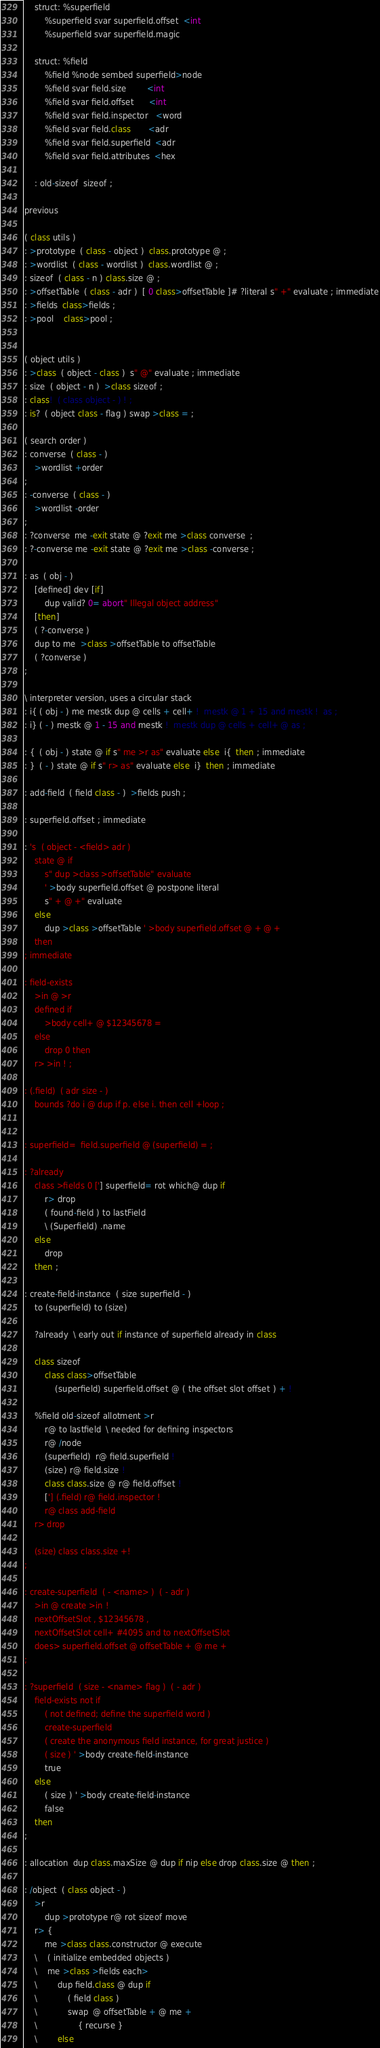<code> <loc_0><loc_0><loc_500><loc_500><_FORTRAN_>    struct: %superfield
        %superfield svar superfield.offset  <int
        %superfield svar superfield.magic
    
    struct: %field 
        %field %node sembed superfield>node 
        %field svar field.size        <int   
        %field svar field.offset      <int      
        %field svar field.inspector   <word    
        %field svar field.class       <adr
        %field svar field.superfield  <adr
        %field svar field.attributes  <hex

    : old-sizeof  sizeof ;    

previous

( class utils )
: >prototype  ( class - object )  class.prototype @ ;
: >wordlist  ( class - wordlist )  class.wordlist @ ;
: sizeof  ( class - n ) class.size @ ;
: >offsetTable  ( class - adr )  [ 0 class>offsetTable ]# ?literal s" +" evaluate ; immediate
: >fields  class>fields ; 
: >pool    class>pool ;


( object utils )
: >class  ( object - class )  s" @" evaluate ; immediate
: size  ( object - n )  >class sizeof ;
: class!  ( class object - ) ! ;
: is?  ( object class - flag ) swap >class = ;

( search order )
: converse  ( class - )
    >wordlist +order
;
: -converse  ( class - )
    >wordlist -order
;
: ?converse  me -exit state @ ?exit me >class converse  ;
: ?-converse me -exit state @ ?exit me >class -converse ;

: as  ( obj - )
    [defined] dev [if]
        dup valid? 0= abort" Illegal object address"
    [then]
    ( ?-converse )
    dup to me  >class >offsetTable to offsetTable
    ( ?converse )
;

\ interpreter version, uses a circular stack
: i{ ( obj - ) me mestk dup @ cells + cell+ !  mestk @ 1 + 15 and mestk !  as ;
: i} ( - ) mestk @ 1 - 15 and mestk !  mestk dup @ cells + cell+ @ as ; 

: {  ( obj - ) state @ if s" me >r as" evaluate else  i{  then ; immediate
: }  ( - ) state @ if s" r> as" evaluate else  i}  then ; immediate

: add-field  ( field class - )  >fields push ;

: superfield.offset ; immediate

: 's  ( object - <field> adr )
    state @ if
        s" dup >class >offsetTable" evaluate
        ' >body superfield.offset @ postpone literal
        s" + @ +" evaluate
    else
        dup >class >offsetTable ' >body superfield.offset @ + @ +
    then
; immediate

: field-exists
    >in @ >r
    defined if
        >body cell+ @ $12345678 =
    else
        drop 0 then
    r> >in ! ;

: (.field)  ( adr size - )
    bounds ?do i @ dup if p. else i. then cell +loop ;


: superfield=  field.superfield @ (superfield) = ;

: ?already
    class >fields 0 ['] superfield= rot which@ dup if
        r> drop
        ( found-field ) to lastField
        \ (Superfield) .name
    else
        drop
    then ;

: create-field-instance  ( size superfield - )
    to (superfield) to (size)
    
    ?already  \ early out if instance of superfield already in class
    
    class sizeof
        class class>offsetTable
            (superfield) superfield.offset @ ( the offset slot offset ) + !
    
    %field old-sizeof allotment >r
        r@ to lastfield  \ needed for defining inspectors
        r@ /node
        (superfield)  r@ field.superfield !
        (size) r@ field.size !
        class class.size @ r@ field.offset !
        ['] (.field) r@ field.inspector !
        r@ class add-field
    r> drop

    (size) class class.size +!
;

: create-superfield  ( - <name> )  ( - adr )
    >in @ create >in !
    nextOffsetSlot , $12345678 ,
    nextOffsetSlot cell+ #4095 and to nextOffsetSlot
    does> superfield.offset @ offsetTable + @ me + 
;

: ?superfield  ( size - <name> flag )  ( - adr )    
    field-exists not if
        ( not defined; define the superfield word )
        create-superfield
        ( create the anonymous field instance, for great justice )
        ( size ) ' >body create-field-instance
        true
    else 
        ( size ) ' >body create-field-instance
        false
    then
;

: allocation  dup class.maxSize @ dup if nip else drop class.size @ then ;

: /object  ( class object - )
    >r 
        dup >prototype r@ rot sizeof move
    r> {
        me >class class.constructor @ execute
    \    ( initialize embedded objects )
    \    me >class >fields each>
    \        dup field.class @ dup if
    \            ( field class )
    \            swap  @ offsetTable + @ me +
    \                { recurse }
    \        else</code> 